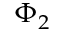Convert formula to latex. <formula><loc_0><loc_0><loc_500><loc_500>\Phi _ { 2 }</formula> 